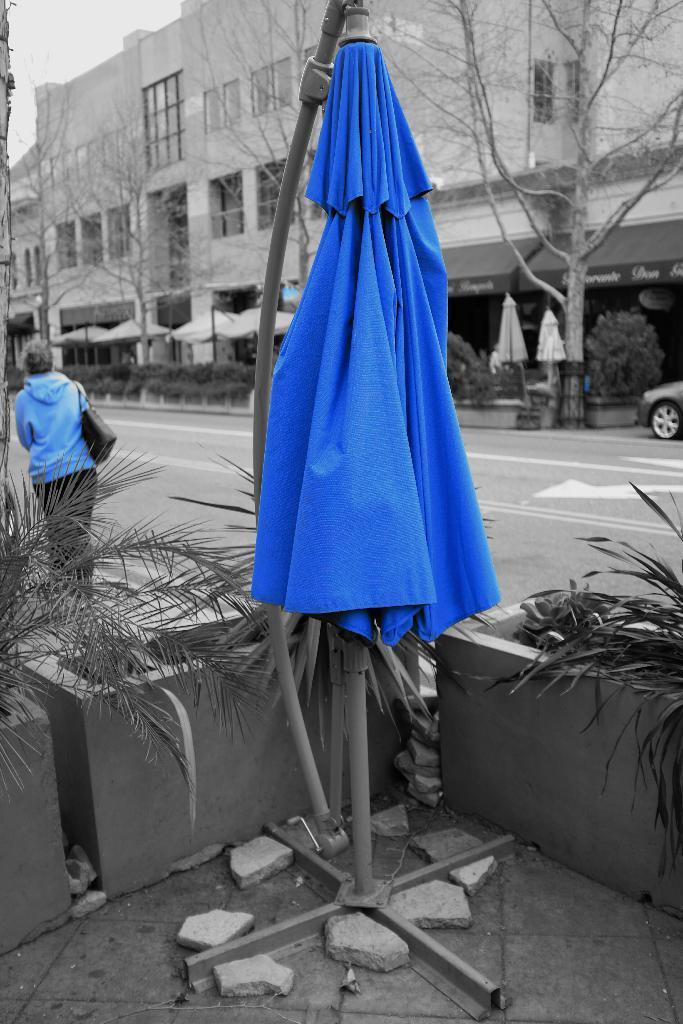Could you give a brief overview of what you see in this image? In this image in the front there is a stand and there is a tent which is blue in colour, there are stones and plants. In the center there is a woman walking. In the background there are tents, plants, dry trees and buildings and there is a car and the sky is cloudy. 